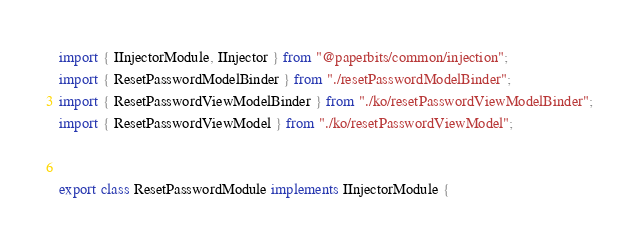<code> <loc_0><loc_0><loc_500><loc_500><_TypeScript_>import { IInjectorModule, IInjector } from "@paperbits/common/injection";
import { ResetPasswordModelBinder } from "./resetPasswordModelBinder";
import { ResetPasswordViewModelBinder } from "./ko/resetPasswordViewModelBinder";
import { ResetPasswordViewModel } from "./ko/resetPasswordViewModel";


export class ResetPasswordModule implements IInjectorModule {</code> 